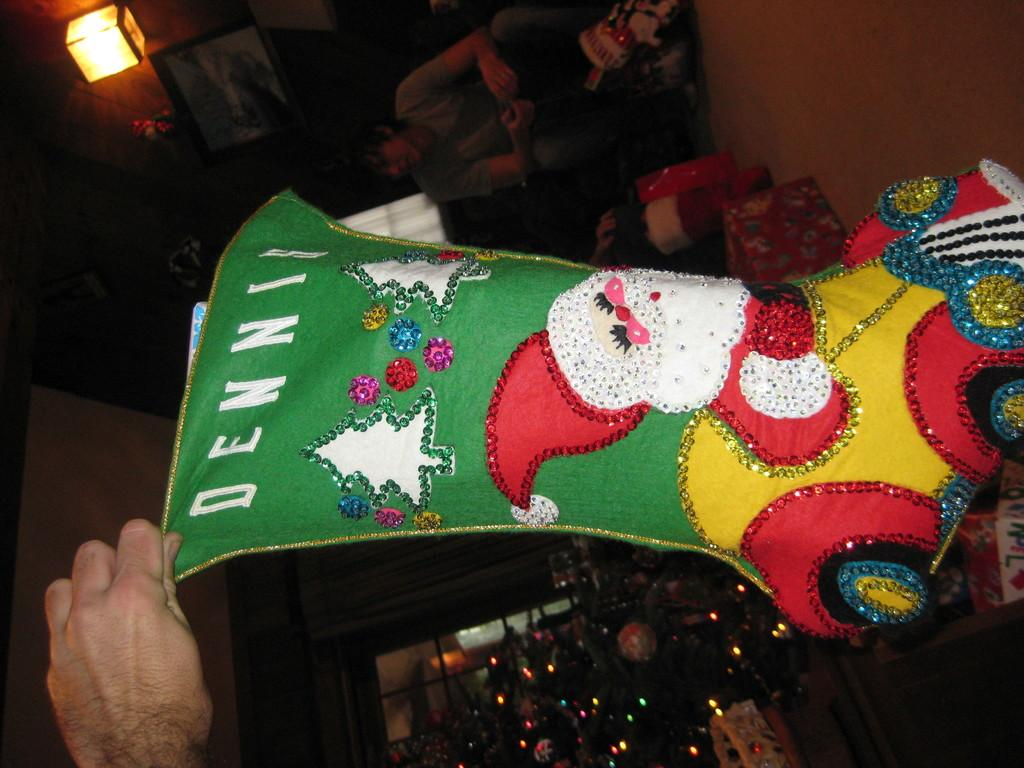What can be seen in the image that provides illumination? There is a light in the image. What type of structure is present in the background? There is a wall in the image. Who or what is present in the image? There are people in the image. What seasonal decoration is visible in the image? There is a Christmas tree in the image. What is associated with the Christmas tree to enhance its appearance? There are lights associated with the Christmas tree. What type of twig can be seen being waved by the people in the image? There is no twig present in the image; the people are not waving anything. How do the people in the image say good-bye to each other? There is no indication in the image of people saying good-bye to each other. 